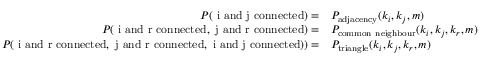Convert formula to latex. <formula><loc_0><loc_0><loc_500><loc_500>\begin{array} { r l } { P ( i a n d j c o n n e c t e d ) = } & { P _ { a d j a c e n c y } ( k _ { i } , k _ { j } , m ) } \\ { P ( i a n d r c o n n e c t e d , j a n d r c o n n e c t e d ) = } & { P _ { c o m m o n n e i g h b o u r } ( k _ { i } , k _ { j } , k _ { r } , m ) } \\ { P ( i a n d r c o n n e c t e d , j a n d r c o n n e c t e d , i a n d j c o n n e c t e d ) ) = } & { P _ { t r i a n g l e } ( k _ { i } , k _ { j } , k _ { r } , m ) } \end{array}</formula> 